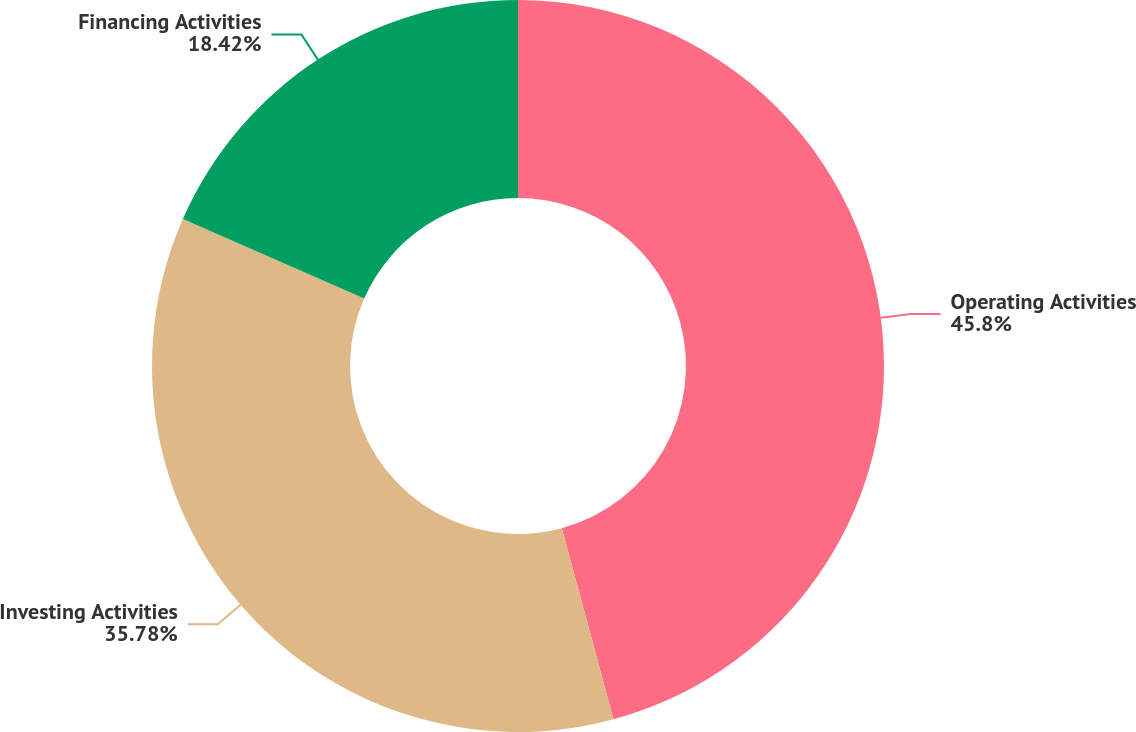Convert chart. <chart><loc_0><loc_0><loc_500><loc_500><pie_chart><fcel>Operating Activities<fcel>Investing Activities<fcel>Financing Activities<nl><fcel>45.8%<fcel>35.78%<fcel>18.42%<nl></chart> 